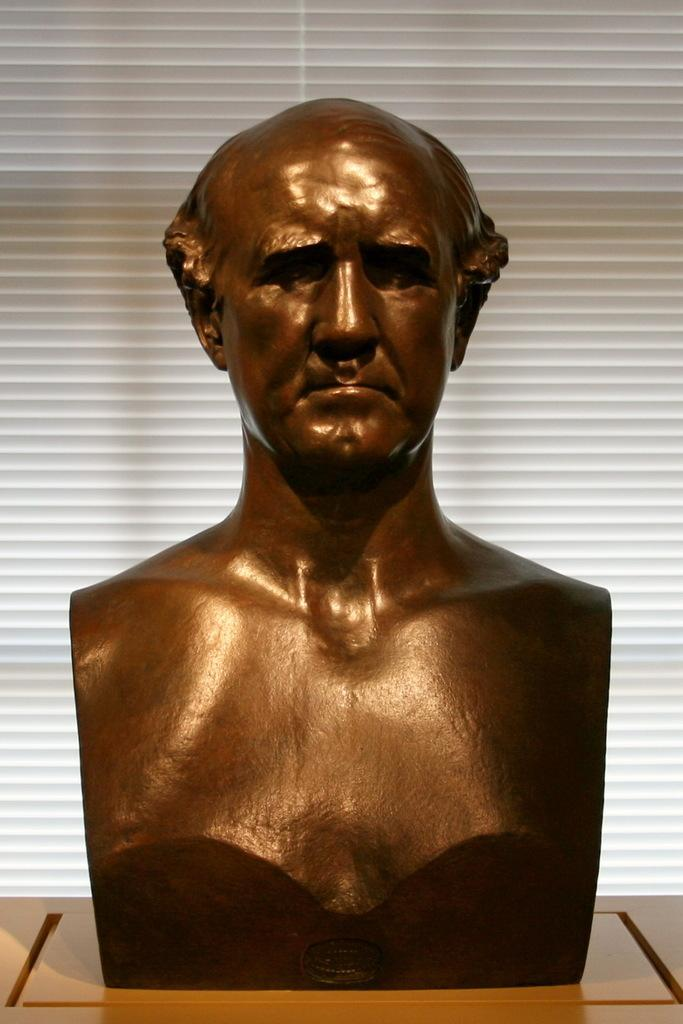What is the main subject of the image? There is a sculpture in the image. Can you describe the sculpture? The sculpture is of a man. Where is the sculpture located in the image? The sculpture is placed on a table. How many mice are climbing on the sculpture in the image? There are no mice present in the image; it features a sculpture of a man on a table. What type of thread is used to create the sculpture? The sculpture is not made of thread; it is a solid object, likely made of a material such as stone or metal. 